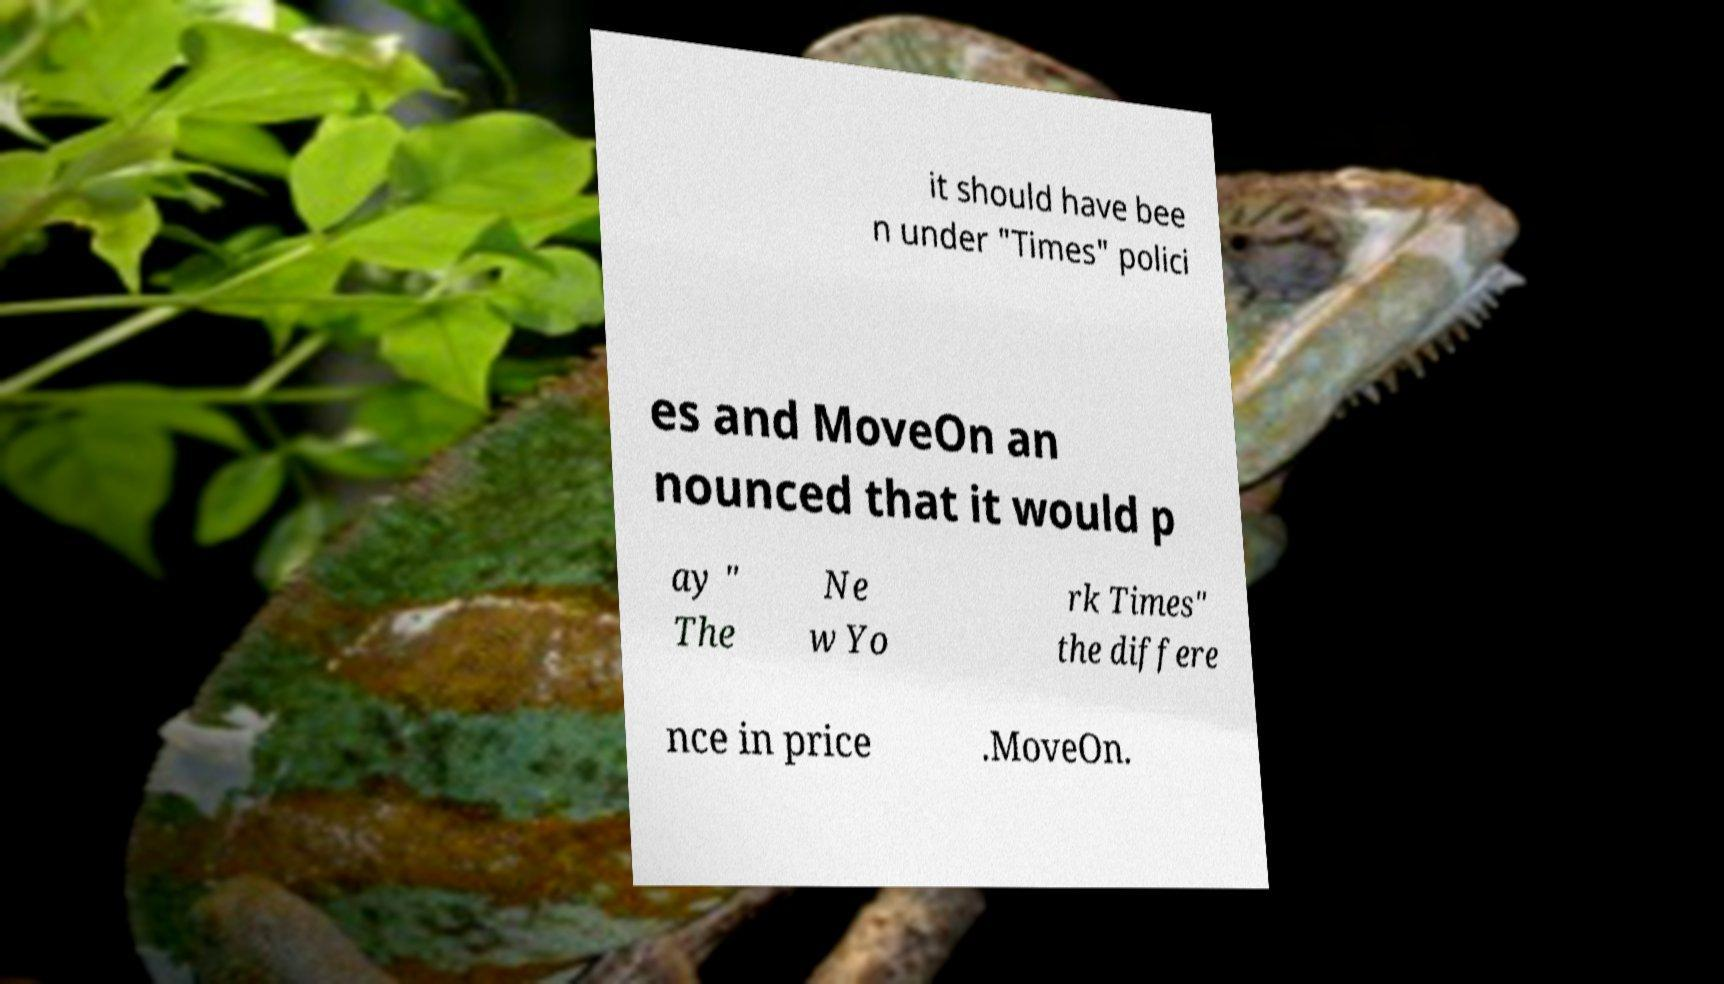What messages or text are displayed in this image? I need them in a readable, typed format. it should have bee n under "Times" polici es and MoveOn an nounced that it would p ay " The Ne w Yo rk Times" the differe nce in price .MoveOn. 